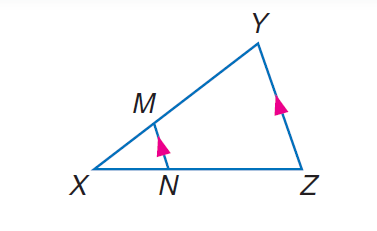Answer the mathemtical geometry problem and directly provide the correct option letter.
Question: If X N = t - 2, N Z = t + 1, X M = 2, and X Y = 10, solve for t.
Choices: A: 3 B: 4 C: 5 D: 8 A 